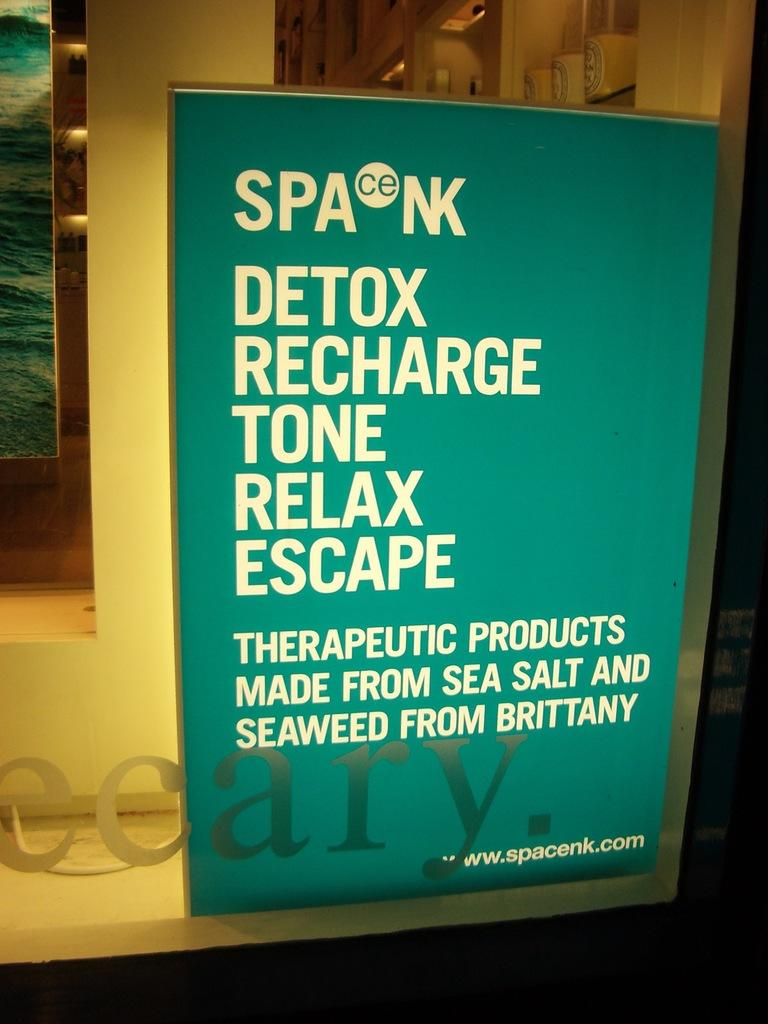Provide a one-sentence caption for the provided image. The ad on the window is for a website called www.spacenk.com. 